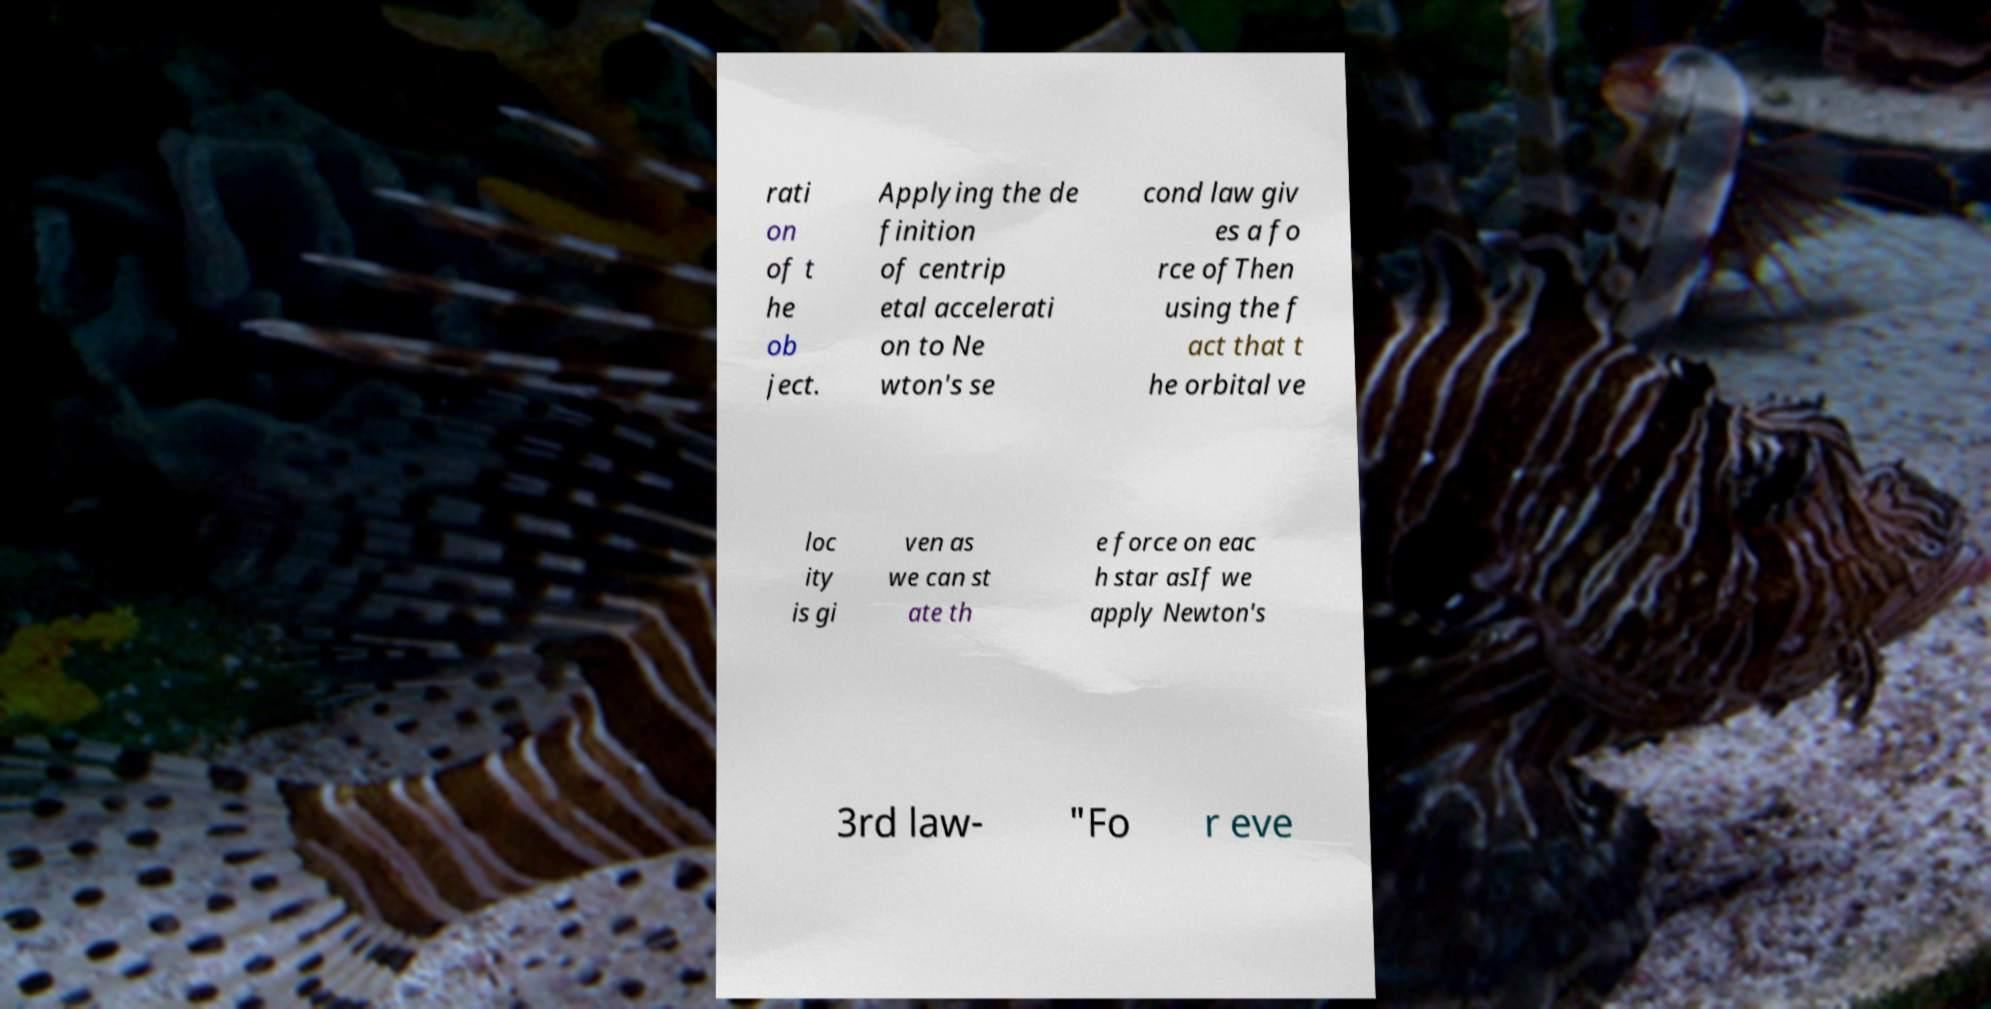For documentation purposes, I need the text within this image transcribed. Could you provide that? rati on of t he ob ject. Applying the de finition of centrip etal accelerati on to Ne wton's se cond law giv es a fo rce ofThen using the f act that t he orbital ve loc ity is gi ven as we can st ate th e force on eac h star asIf we apply Newton's 3rd law- "Fo r eve 